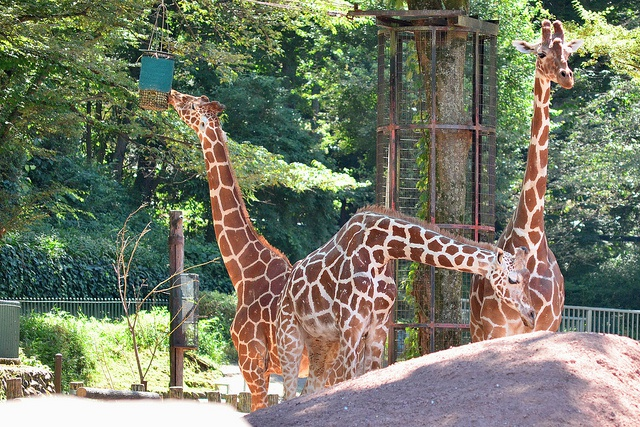Describe the objects in this image and their specific colors. I can see giraffe in black, brown, lightgray, darkgray, and maroon tones, giraffe in black, brown, maroon, and tan tones, and giraffe in black, brown, lightgray, and tan tones in this image. 